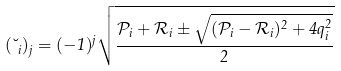<formula> <loc_0><loc_0><loc_500><loc_500>( \lambda _ { i } ) _ { j } = ( - 1 ) ^ { j } \sqrt { \frac { \mathcal { P } _ { i } + \mathcal { R } _ { i } \pm \sqrt { ( \mathcal { P } _ { i } - \mathcal { R } _ { i } ) ^ { 2 } + 4 q _ { i } ^ { 2 } } } { 2 } }</formula> 